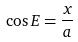<formula> <loc_0><loc_0><loc_500><loc_500>\cos E = \frac { x } { a }</formula> 